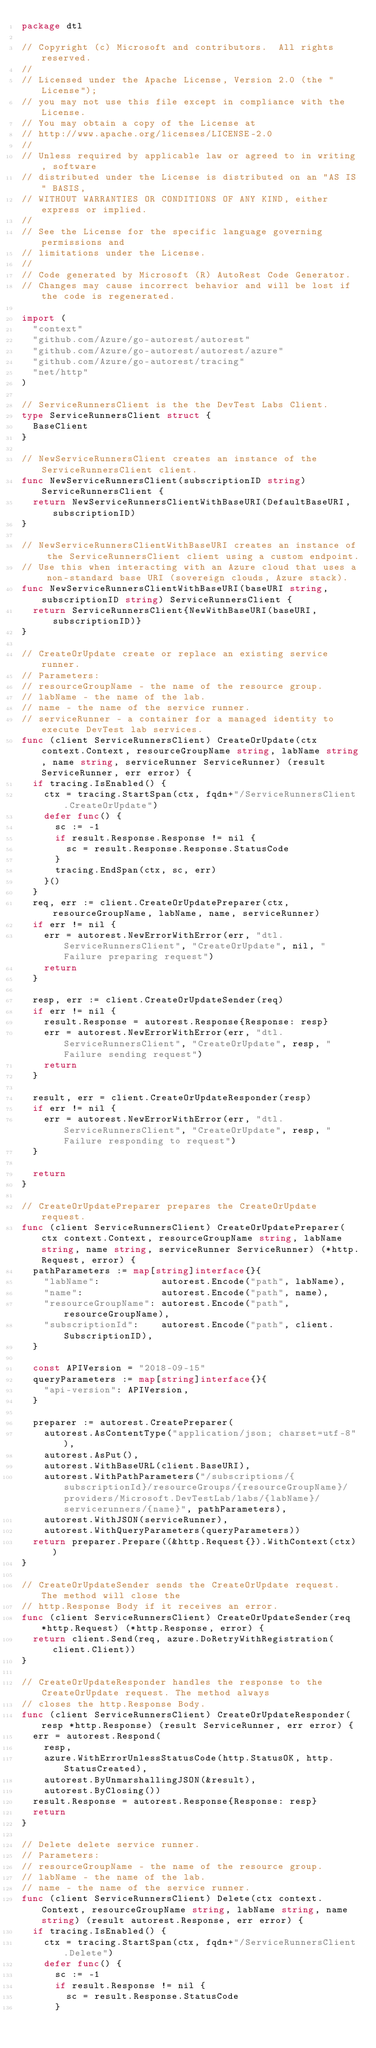<code> <loc_0><loc_0><loc_500><loc_500><_Go_>package dtl

// Copyright (c) Microsoft and contributors.  All rights reserved.
//
// Licensed under the Apache License, Version 2.0 (the "License");
// you may not use this file except in compliance with the License.
// You may obtain a copy of the License at
// http://www.apache.org/licenses/LICENSE-2.0
//
// Unless required by applicable law or agreed to in writing, software
// distributed under the License is distributed on an "AS IS" BASIS,
// WITHOUT WARRANTIES OR CONDITIONS OF ANY KIND, either express or implied.
//
// See the License for the specific language governing permissions and
// limitations under the License.
//
// Code generated by Microsoft (R) AutoRest Code Generator.
// Changes may cause incorrect behavior and will be lost if the code is regenerated.

import (
	"context"
	"github.com/Azure/go-autorest/autorest"
	"github.com/Azure/go-autorest/autorest/azure"
	"github.com/Azure/go-autorest/tracing"
	"net/http"
)

// ServiceRunnersClient is the the DevTest Labs Client.
type ServiceRunnersClient struct {
	BaseClient
}

// NewServiceRunnersClient creates an instance of the ServiceRunnersClient client.
func NewServiceRunnersClient(subscriptionID string) ServiceRunnersClient {
	return NewServiceRunnersClientWithBaseURI(DefaultBaseURI, subscriptionID)
}

// NewServiceRunnersClientWithBaseURI creates an instance of the ServiceRunnersClient client using a custom endpoint.
// Use this when interacting with an Azure cloud that uses a non-standard base URI (sovereign clouds, Azure stack).
func NewServiceRunnersClientWithBaseURI(baseURI string, subscriptionID string) ServiceRunnersClient {
	return ServiceRunnersClient{NewWithBaseURI(baseURI, subscriptionID)}
}

// CreateOrUpdate create or replace an existing service runner.
// Parameters:
// resourceGroupName - the name of the resource group.
// labName - the name of the lab.
// name - the name of the service runner.
// serviceRunner - a container for a managed identity to execute DevTest lab services.
func (client ServiceRunnersClient) CreateOrUpdate(ctx context.Context, resourceGroupName string, labName string, name string, serviceRunner ServiceRunner) (result ServiceRunner, err error) {
	if tracing.IsEnabled() {
		ctx = tracing.StartSpan(ctx, fqdn+"/ServiceRunnersClient.CreateOrUpdate")
		defer func() {
			sc := -1
			if result.Response.Response != nil {
				sc = result.Response.Response.StatusCode
			}
			tracing.EndSpan(ctx, sc, err)
		}()
	}
	req, err := client.CreateOrUpdatePreparer(ctx, resourceGroupName, labName, name, serviceRunner)
	if err != nil {
		err = autorest.NewErrorWithError(err, "dtl.ServiceRunnersClient", "CreateOrUpdate", nil, "Failure preparing request")
		return
	}

	resp, err := client.CreateOrUpdateSender(req)
	if err != nil {
		result.Response = autorest.Response{Response: resp}
		err = autorest.NewErrorWithError(err, "dtl.ServiceRunnersClient", "CreateOrUpdate", resp, "Failure sending request")
		return
	}

	result, err = client.CreateOrUpdateResponder(resp)
	if err != nil {
		err = autorest.NewErrorWithError(err, "dtl.ServiceRunnersClient", "CreateOrUpdate", resp, "Failure responding to request")
	}

	return
}

// CreateOrUpdatePreparer prepares the CreateOrUpdate request.
func (client ServiceRunnersClient) CreateOrUpdatePreparer(ctx context.Context, resourceGroupName string, labName string, name string, serviceRunner ServiceRunner) (*http.Request, error) {
	pathParameters := map[string]interface{}{
		"labName":           autorest.Encode("path", labName),
		"name":              autorest.Encode("path", name),
		"resourceGroupName": autorest.Encode("path", resourceGroupName),
		"subscriptionId":    autorest.Encode("path", client.SubscriptionID),
	}

	const APIVersion = "2018-09-15"
	queryParameters := map[string]interface{}{
		"api-version": APIVersion,
	}

	preparer := autorest.CreatePreparer(
		autorest.AsContentType("application/json; charset=utf-8"),
		autorest.AsPut(),
		autorest.WithBaseURL(client.BaseURI),
		autorest.WithPathParameters("/subscriptions/{subscriptionId}/resourceGroups/{resourceGroupName}/providers/Microsoft.DevTestLab/labs/{labName}/servicerunners/{name}", pathParameters),
		autorest.WithJSON(serviceRunner),
		autorest.WithQueryParameters(queryParameters))
	return preparer.Prepare((&http.Request{}).WithContext(ctx))
}

// CreateOrUpdateSender sends the CreateOrUpdate request. The method will close the
// http.Response Body if it receives an error.
func (client ServiceRunnersClient) CreateOrUpdateSender(req *http.Request) (*http.Response, error) {
	return client.Send(req, azure.DoRetryWithRegistration(client.Client))
}

// CreateOrUpdateResponder handles the response to the CreateOrUpdate request. The method always
// closes the http.Response Body.
func (client ServiceRunnersClient) CreateOrUpdateResponder(resp *http.Response) (result ServiceRunner, err error) {
	err = autorest.Respond(
		resp,
		azure.WithErrorUnlessStatusCode(http.StatusOK, http.StatusCreated),
		autorest.ByUnmarshallingJSON(&result),
		autorest.ByClosing())
	result.Response = autorest.Response{Response: resp}
	return
}

// Delete delete service runner.
// Parameters:
// resourceGroupName - the name of the resource group.
// labName - the name of the lab.
// name - the name of the service runner.
func (client ServiceRunnersClient) Delete(ctx context.Context, resourceGroupName string, labName string, name string) (result autorest.Response, err error) {
	if tracing.IsEnabled() {
		ctx = tracing.StartSpan(ctx, fqdn+"/ServiceRunnersClient.Delete")
		defer func() {
			sc := -1
			if result.Response != nil {
				sc = result.Response.StatusCode
			}</code> 